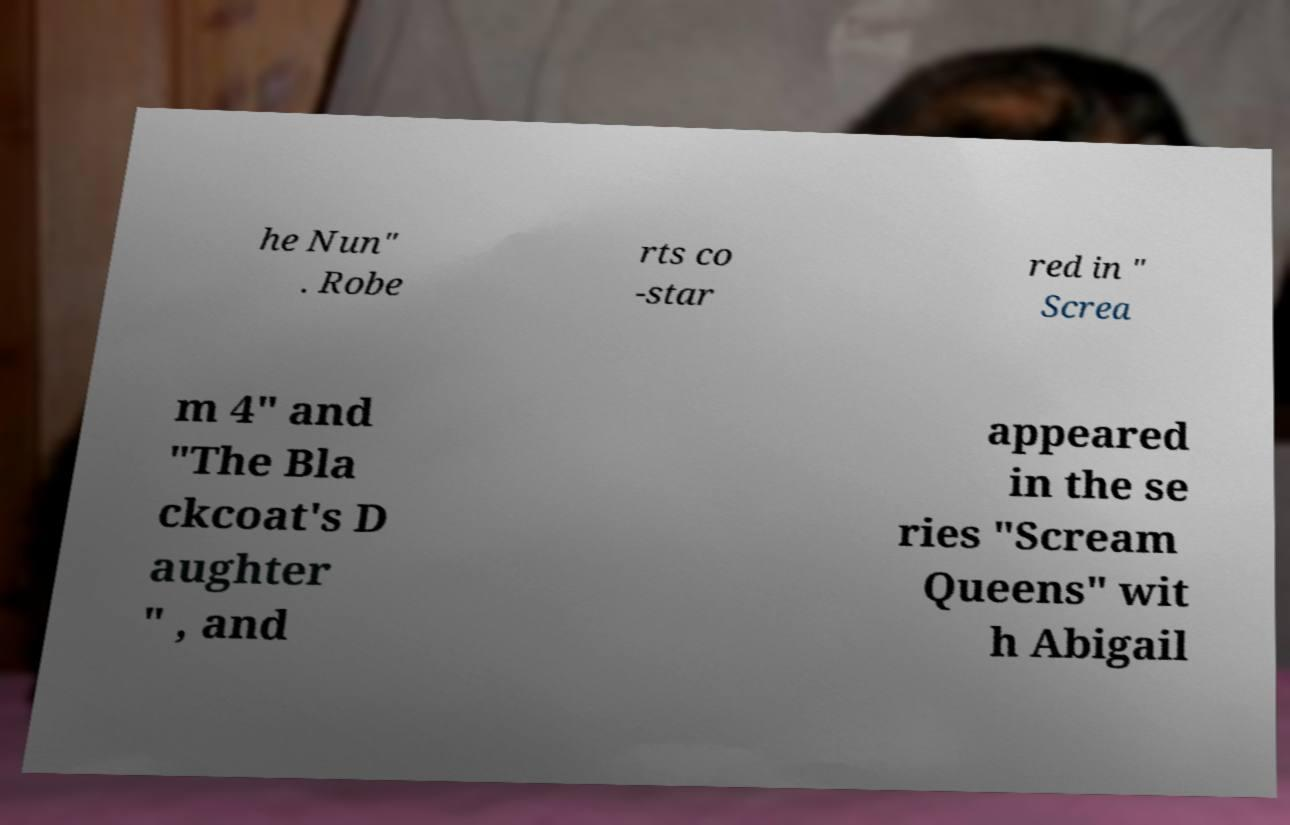Can you read and provide the text displayed in the image?This photo seems to have some interesting text. Can you extract and type it out for me? he Nun" . Robe rts co -star red in " Screa m 4" and "The Bla ckcoat's D aughter " , and appeared in the se ries "Scream Queens" wit h Abigail 